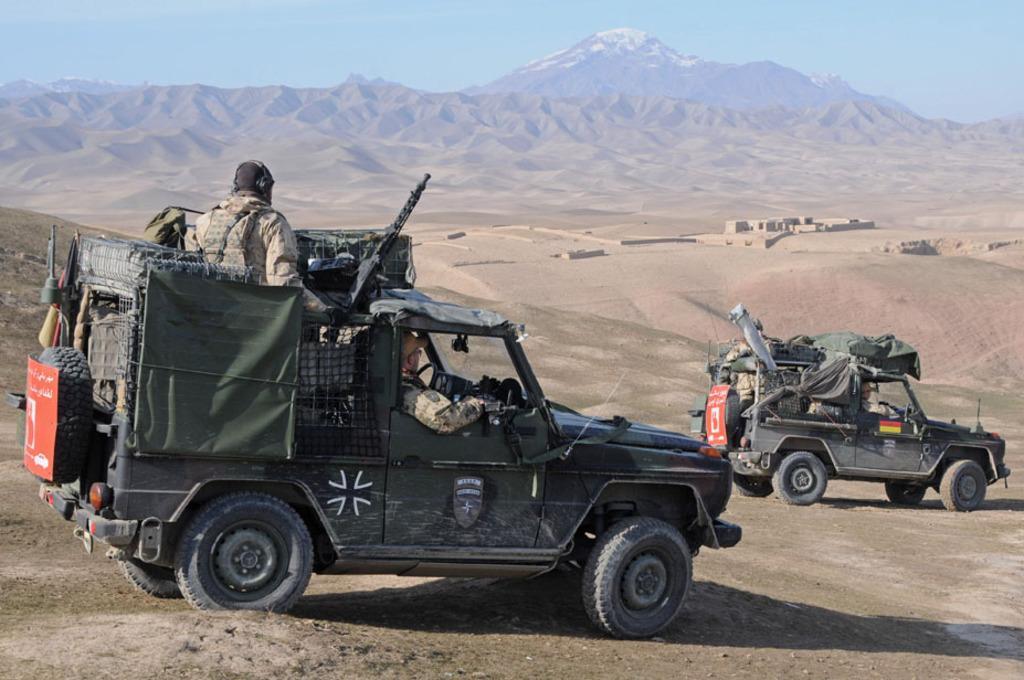Can you describe this image briefly? In this image there are two vehicles and some persons are sitting on vehicles and driving, and in the vehicles there are some guns, bags and some other objects. And at the bottom there is sand, in the background there are some mountains. On the top of the image there is sky. 